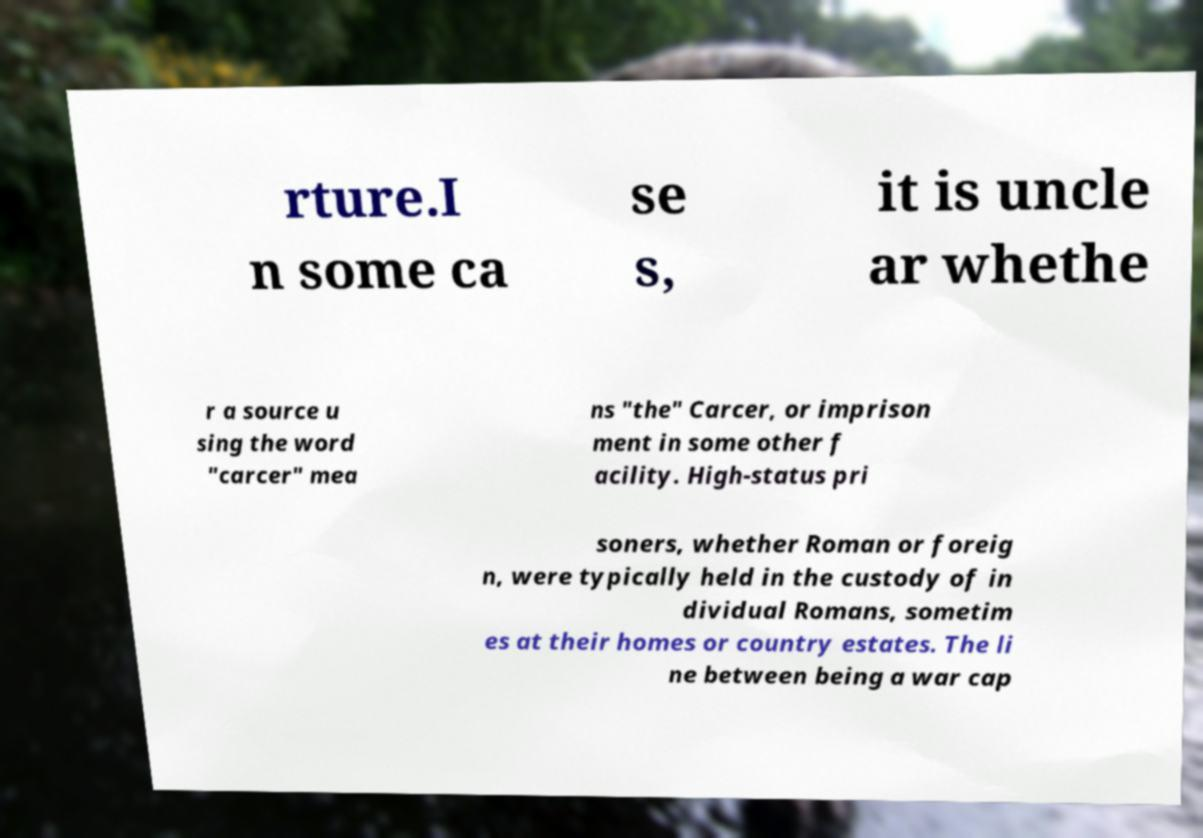For documentation purposes, I need the text within this image transcribed. Could you provide that? rture.I n some ca se s, it is uncle ar whethe r a source u sing the word "carcer" mea ns "the" Carcer, or imprison ment in some other f acility. High-status pri soners, whether Roman or foreig n, were typically held in the custody of in dividual Romans, sometim es at their homes or country estates. The li ne between being a war cap 